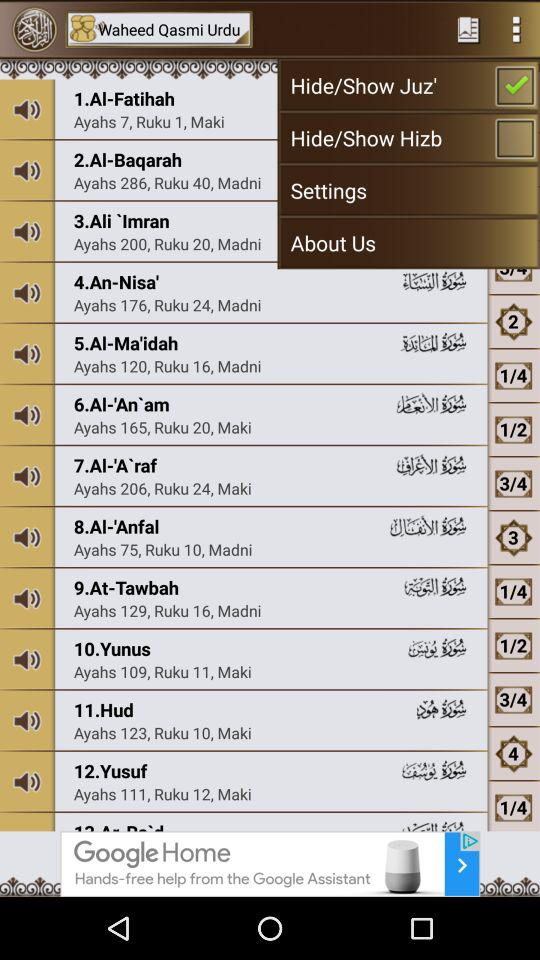What is the number of ruku in "An-Nisa'"? There are 24 rukus in "An-Nisa'". 